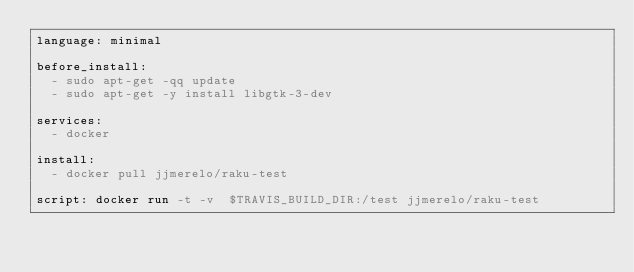Convert code to text. <code><loc_0><loc_0><loc_500><loc_500><_YAML_>language: minimal

before_install:
  - sudo apt-get -qq update
  - sudo apt-get -y install libgtk-3-dev

services:
  - docker

install:
  - docker pull jjmerelo/raku-test

script: docker run -t -v  $TRAVIS_BUILD_DIR:/test jjmerelo/raku-test
</code> 